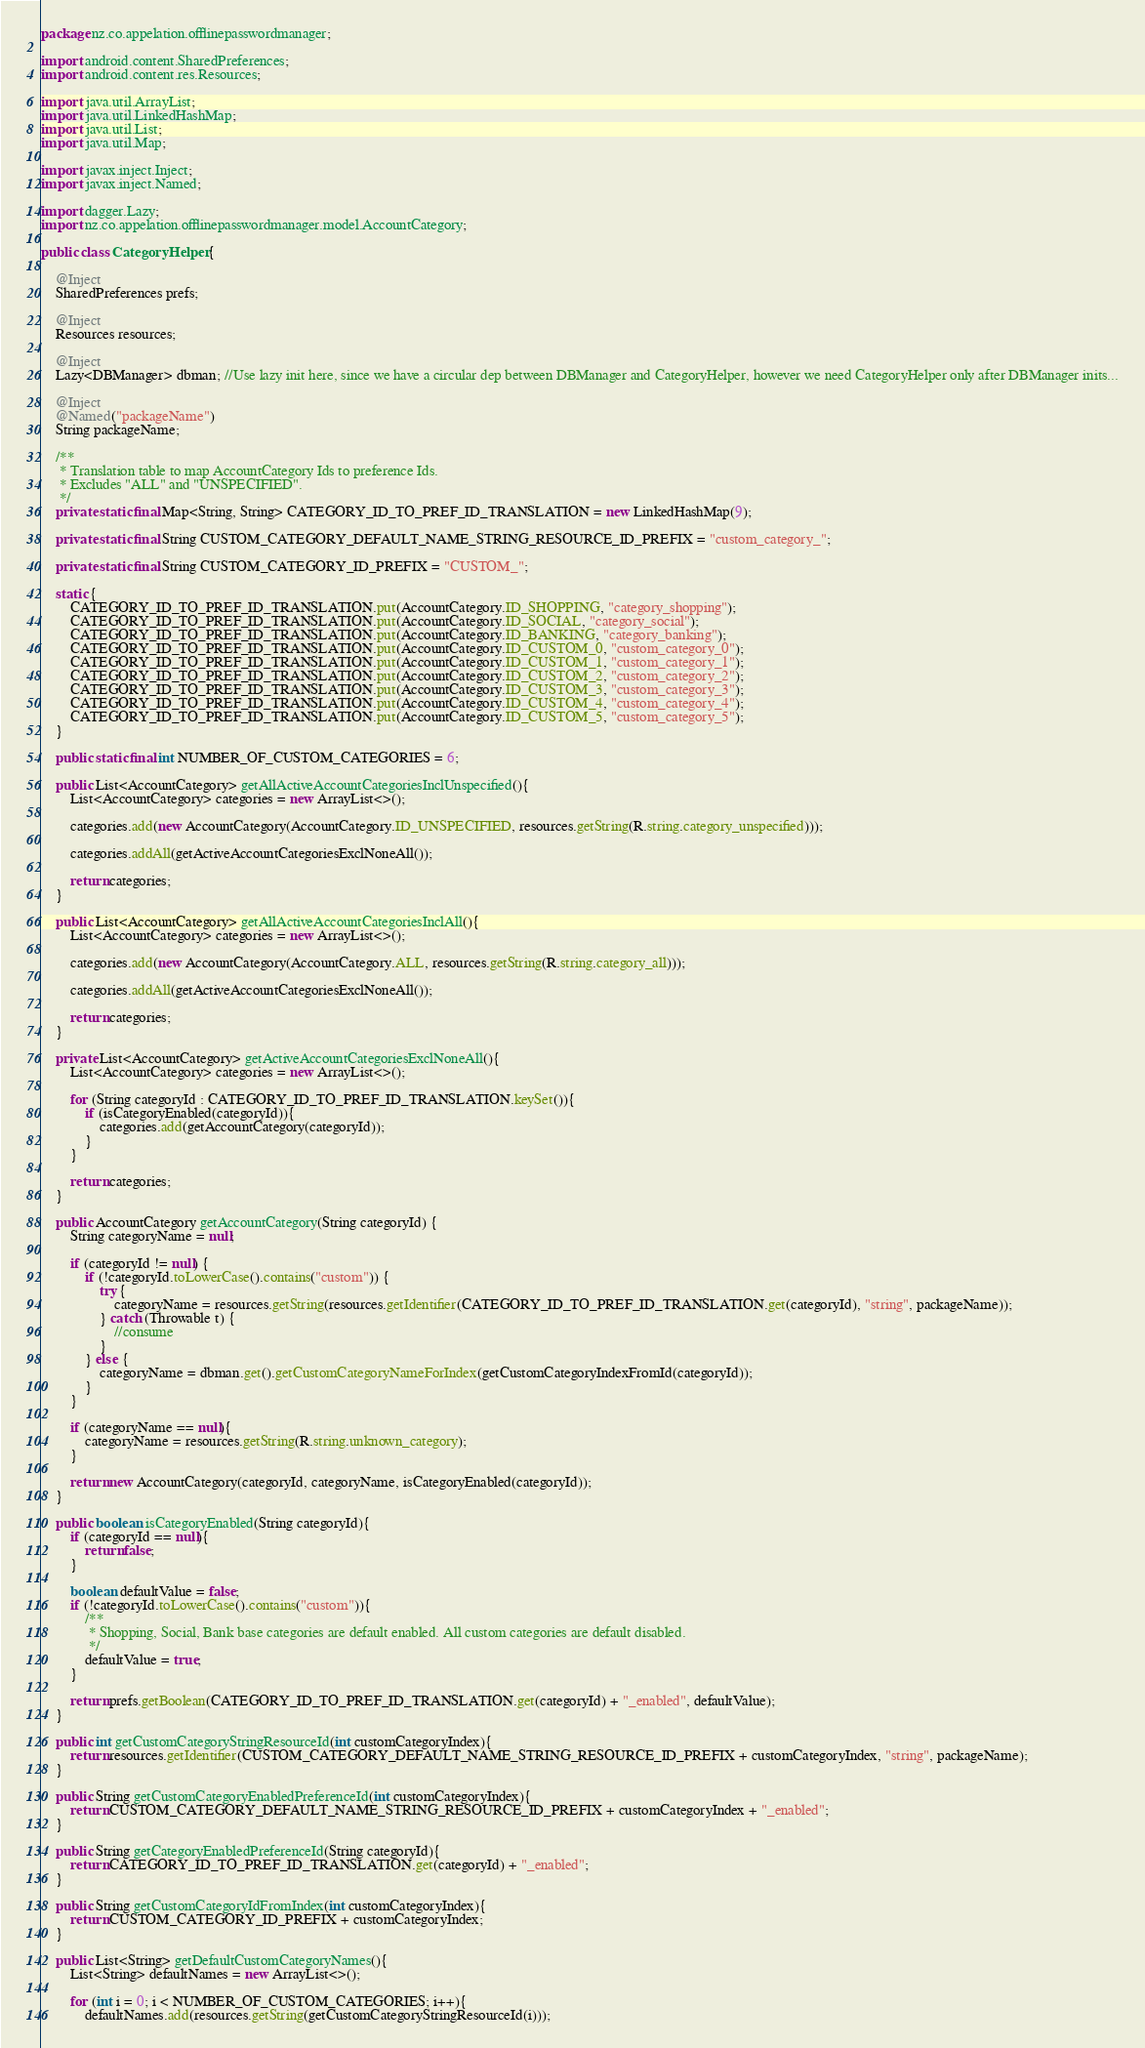<code> <loc_0><loc_0><loc_500><loc_500><_Java_>package nz.co.appelation.offlinepasswordmanager;

import android.content.SharedPreferences;
import android.content.res.Resources;

import java.util.ArrayList;
import java.util.LinkedHashMap;
import java.util.List;
import java.util.Map;

import javax.inject.Inject;
import javax.inject.Named;

import dagger.Lazy;
import nz.co.appelation.offlinepasswordmanager.model.AccountCategory;

public class CategoryHelper {

    @Inject
    SharedPreferences prefs;

    @Inject
    Resources resources;

    @Inject
    Lazy<DBManager> dbman; //Use lazy init here, since we have a circular dep between DBManager and CategoryHelper, however we need CategoryHelper only after DBManager inits...

    @Inject
    @Named("packageName")
    String packageName;

    /**
     * Translation table to map AccountCategory Ids to preference Ids.
     * Excludes "ALL" and "UNSPECIFIED".
     */
    private static final Map<String, String> CATEGORY_ID_TO_PREF_ID_TRANSLATION = new LinkedHashMap(9);

    private static final String CUSTOM_CATEGORY_DEFAULT_NAME_STRING_RESOURCE_ID_PREFIX = "custom_category_";

    private static final String CUSTOM_CATEGORY_ID_PREFIX = "CUSTOM_";

    static {
        CATEGORY_ID_TO_PREF_ID_TRANSLATION.put(AccountCategory.ID_SHOPPING, "category_shopping");
        CATEGORY_ID_TO_PREF_ID_TRANSLATION.put(AccountCategory.ID_SOCIAL, "category_social");
        CATEGORY_ID_TO_PREF_ID_TRANSLATION.put(AccountCategory.ID_BANKING, "category_banking");
        CATEGORY_ID_TO_PREF_ID_TRANSLATION.put(AccountCategory.ID_CUSTOM_0, "custom_category_0");
        CATEGORY_ID_TO_PREF_ID_TRANSLATION.put(AccountCategory.ID_CUSTOM_1, "custom_category_1");
        CATEGORY_ID_TO_PREF_ID_TRANSLATION.put(AccountCategory.ID_CUSTOM_2, "custom_category_2");
        CATEGORY_ID_TO_PREF_ID_TRANSLATION.put(AccountCategory.ID_CUSTOM_3, "custom_category_3");
        CATEGORY_ID_TO_PREF_ID_TRANSLATION.put(AccountCategory.ID_CUSTOM_4, "custom_category_4");
        CATEGORY_ID_TO_PREF_ID_TRANSLATION.put(AccountCategory.ID_CUSTOM_5, "custom_category_5");
    }

    public static final int NUMBER_OF_CUSTOM_CATEGORIES = 6;

    public List<AccountCategory> getAllActiveAccountCategoriesInclUnspecified(){
        List<AccountCategory> categories = new ArrayList<>();

        categories.add(new AccountCategory(AccountCategory.ID_UNSPECIFIED, resources.getString(R.string.category_unspecified)));

        categories.addAll(getActiveAccountCategoriesExclNoneAll());

        return categories;
    }

    public List<AccountCategory> getAllActiveAccountCategoriesInclAll(){
        List<AccountCategory> categories = new ArrayList<>();

        categories.add(new AccountCategory(AccountCategory.ALL, resources.getString(R.string.category_all)));

        categories.addAll(getActiveAccountCategoriesExclNoneAll());

        return categories;
    }

    private List<AccountCategory> getActiveAccountCategoriesExclNoneAll(){
        List<AccountCategory> categories = new ArrayList<>();

        for (String categoryId : CATEGORY_ID_TO_PREF_ID_TRANSLATION.keySet()){
            if (isCategoryEnabled(categoryId)){
                categories.add(getAccountCategory(categoryId));
            }
        }

        return categories;
    }

    public AccountCategory getAccountCategory(String categoryId) {
        String categoryName = null;

        if (categoryId != null) {
            if (!categoryId.toLowerCase().contains("custom")) {
                try {
                    categoryName = resources.getString(resources.getIdentifier(CATEGORY_ID_TO_PREF_ID_TRANSLATION.get(categoryId), "string", packageName));
                } catch (Throwable t) {
                    //consume
                }
            } else {
                categoryName = dbman.get().getCustomCategoryNameForIndex(getCustomCategoryIndexFromId(categoryId));
            }
        }

        if (categoryName == null){
            categoryName = resources.getString(R.string.unknown_category);
        }

        return new AccountCategory(categoryId, categoryName, isCategoryEnabled(categoryId));
    }

    public boolean isCategoryEnabled(String categoryId){
        if (categoryId == null){
            return false;
        }

        boolean defaultValue = false;
        if (!categoryId.toLowerCase().contains("custom")){
            /**
             * Shopping, Social, Bank base categories are default enabled. All custom categories are default disabled.
             */
            defaultValue = true;
        }

        return prefs.getBoolean(CATEGORY_ID_TO_PREF_ID_TRANSLATION.get(categoryId) + "_enabled", defaultValue);
    }

    public int getCustomCategoryStringResourceId(int customCategoryIndex){
        return resources.getIdentifier(CUSTOM_CATEGORY_DEFAULT_NAME_STRING_RESOURCE_ID_PREFIX + customCategoryIndex, "string", packageName);
    }

    public String getCustomCategoryEnabledPreferenceId(int customCategoryIndex){
        return CUSTOM_CATEGORY_DEFAULT_NAME_STRING_RESOURCE_ID_PREFIX + customCategoryIndex + "_enabled";
    }

    public String getCategoryEnabledPreferenceId(String categoryId){
        return CATEGORY_ID_TO_PREF_ID_TRANSLATION.get(categoryId) + "_enabled";
    }

    public String getCustomCategoryIdFromIndex(int customCategoryIndex){
        return CUSTOM_CATEGORY_ID_PREFIX + customCategoryIndex;
    }

    public List<String> getDefaultCustomCategoryNames(){
        List<String> defaultNames = new ArrayList<>();

        for (int i = 0; i < NUMBER_OF_CUSTOM_CATEGORIES; i++){
            defaultNames.add(resources.getString(getCustomCategoryStringResourceId(i)));</code> 